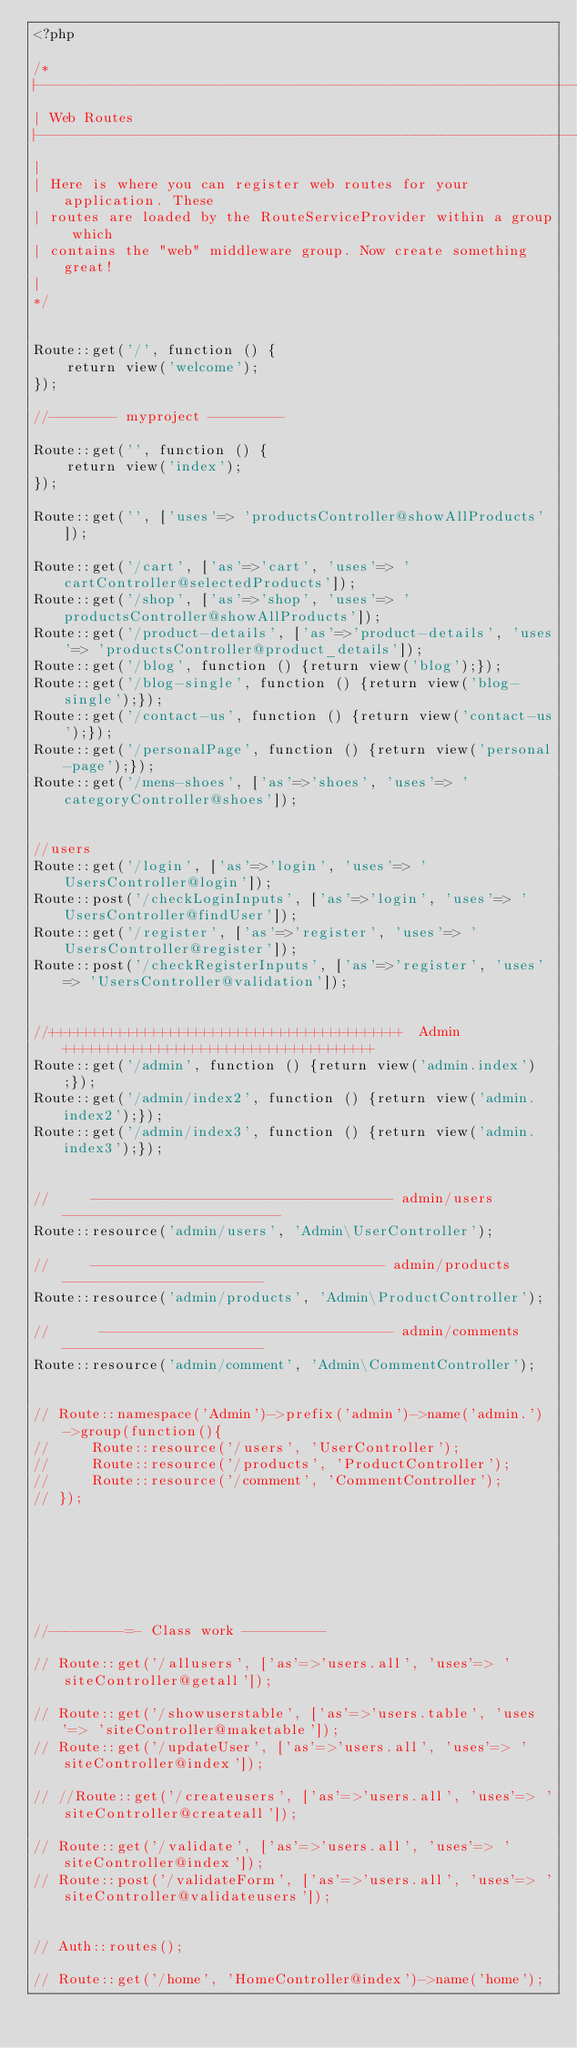<code> <loc_0><loc_0><loc_500><loc_500><_PHP_><?php

/*
|--------------------------------------------------------------------------
| Web Routes
|--------------------------------------------------------------------------
|
| Here is where you can register web routes for your application. These
| routes are loaded by the RouteServiceProvider within a group which
| contains the "web" middleware group. Now create something great!
|
*/


Route::get('/', function () {
    return view('welcome');
});

//-------- myproject ---------

Route::get('', function () {
    return view('index');
});

Route::get('', ['uses'=> 'productsController@showAllProducts']);

Route::get('/cart', ['as'=>'cart', 'uses'=> 'cartController@selectedProducts']);
Route::get('/shop', ['as'=>'shop', 'uses'=> 'productsController@showAllProducts']);
Route::get('/product-details', ['as'=>'product-details', 'uses'=> 'productsController@product_details']);
Route::get('/blog', function () {return view('blog');});
Route::get('/blog-single', function () {return view('blog-single');});
Route::get('/contact-us', function () {return view('contact-us');});
Route::get('/personalPage', function () {return view('personal-page');});
Route::get('/mens-shoes', ['as'=>'shoes', 'uses'=> 'categoryController@shoes']);


//users
Route::get('/login', ['as'=>'login', 'uses'=> 'UsersController@login']);
Route::post('/checkLoginInputs', ['as'=>'login', 'uses'=> 'UsersController@findUser']);
Route::get('/register', ['as'=>'register', 'uses'=> 'UsersController@register']);
Route::post('/checkRegisterInputs', ['as'=>'register', 'uses'=> 'UsersController@validation']);


//++++++++++++++++++++++++++++++++++++++++++  Admin   +++++++++++++++++++++++++++++++++++++
Route::get('/admin', function () {return view('admin.index');});
Route::get('/admin/index2', function () {return view('admin.index2');});
Route::get('/admin/index3', function () {return view('admin.index3');});


//     ------------------------------------ admin/users   --------------------------
Route::resource('admin/users', 'Admin\UserController');

//     ----------------------------------- admin/products   ------------------------
Route::resource('admin/products', 'Admin\ProductController');

//      ----------------------------------- admin/comments   ------------------------
Route::resource('admin/comment', 'Admin\CommentController');


// Route::namespace('Admin')->prefix('admin')->name('admin.')->group(function(){
//     Route::resource('/users', 'UserController');
//     Route::resource('/products', 'ProductController');
//     Route::resource('/comment', 'CommentController');
// });







//---------=- Class work ----------

// Route::get('/allusers', ['as'=>'users.all', 'uses'=> 'siteController@getall']);

// Route::get('/showuserstable', ['as'=>'users.table', 'uses'=> 'siteController@maketable']);
// Route::get('/updateUser', ['as'=>'users.all', 'uses'=> 'siteController@index']);

// //Route::get('/createusers', ['as'=>'users.all', 'uses'=> 'siteController@createall']);

// Route::get('/validate', ['as'=>'users.all', 'uses'=> 'siteController@index']);
// Route::post('/validateForm', ['as'=>'users.all', 'uses'=> 'siteController@validateusers']);


// Auth::routes();

// Route::get('/home', 'HomeController@index')->name('home');







</code> 